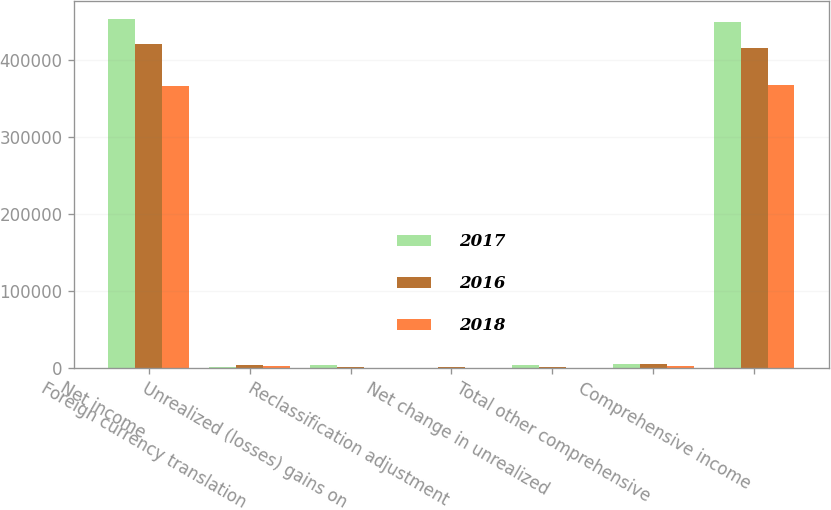Convert chart to OTSL. <chart><loc_0><loc_0><loc_500><loc_500><stacked_bar_chart><ecel><fcel>Net income<fcel>Foreign currency translation<fcel>Unrealized (losses) gains on<fcel>Reclassification adjustment<fcel>Net change in unrealized<fcel>Total other comprehensive<fcel>Comprehensive income<nl><fcel>2017<fcel>453689<fcel>1415<fcel>2775<fcel>9<fcel>2766<fcel>4181<fcel>449508<nl><fcel>2016<fcel>420761<fcel>3671<fcel>822<fcel>310<fcel>1132<fcel>4803<fcel>415958<nl><fcel>2018<fcel>365855<fcel>2067<fcel>23<fcel>4<fcel>27<fcel>2094<fcel>367949<nl></chart> 